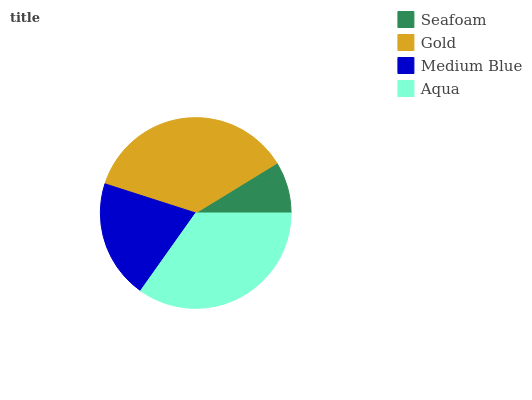Is Seafoam the minimum?
Answer yes or no. Yes. Is Gold the maximum?
Answer yes or no. Yes. Is Medium Blue the minimum?
Answer yes or no. No. Is Medium Blue the maximum?
Answer yes or no. No. Is Gold greater than Medium Blue?
Answer yes or no. Yes. Is Medium Blue less than Gold?
Answer yes or no. Yes. Is Medium Blue greater than Gold?
Answer yes or no. No. Is Gold less than Medium Blue?
Answer yes or no. No. Is Aqua the high median?
Answer yes or no. Yes. Is Medium Blue the low median?
Answer yes or no. Yes. Is Gold the high median?
Answer yes or no. No. Is Seafoam the low median?
Answer yes or no. No. 